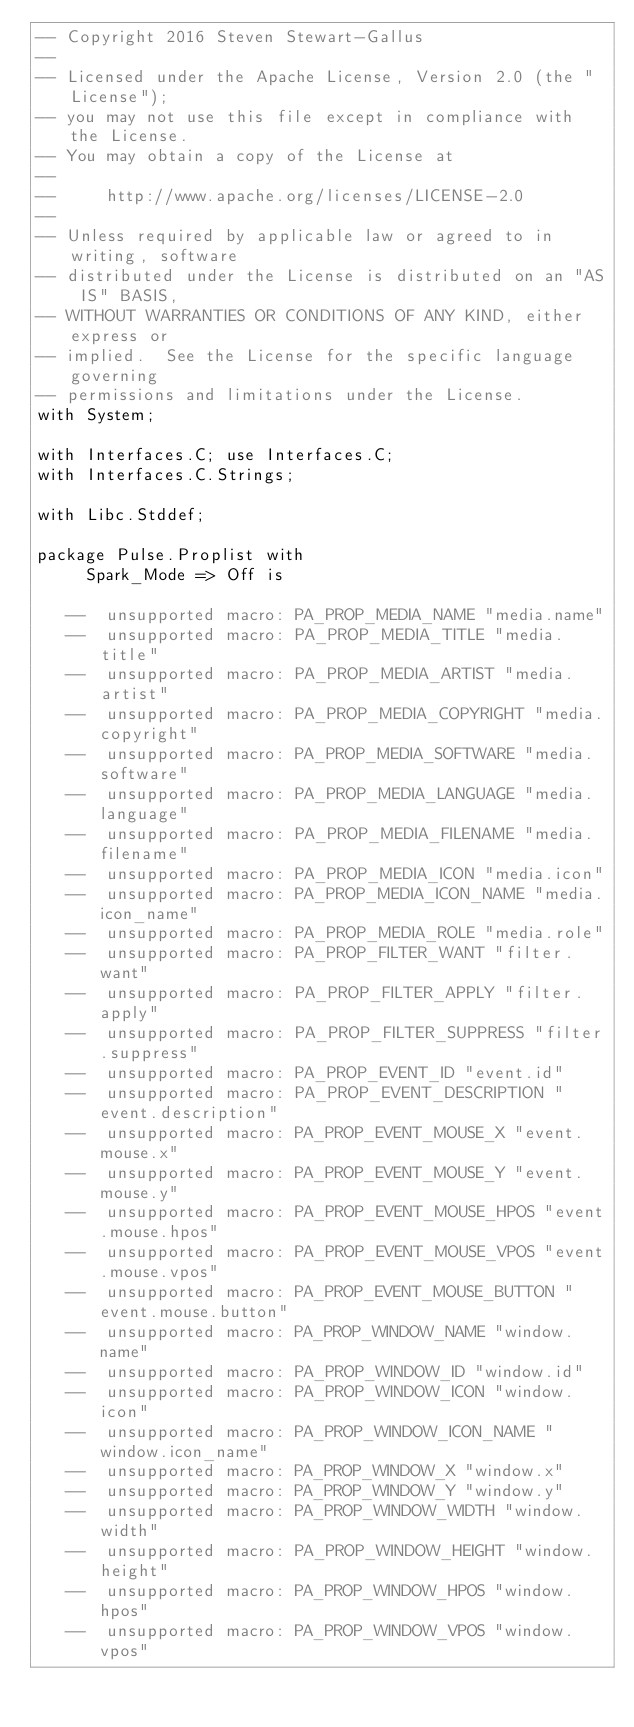Convert code to text. <code><loc_0><loc_0><loc_500><loc_500><_Ada_>-- Copyright 2016 Steven Stewart-Gallus
--
-- Licensed under the Apache License, Version 2.0 (the "License");
-- you may not use this file except in compliance with the License.
-- You may obtain a copy of the License at
--
--     http://www.apache.org/licenses/LICENSE-2.0
--
-- Unless required by applicable law or agreed to in writing, software
-- distributed under the License is distributed on an "AS IS" BASIS,
-- WITHOUT WARRANTIES OR CONDITIONS OF ANY KIND, either express or
-- implied.  See the License for the specific language governing
-- permissions and limitations under the License.
with System;

with Interfaces.C; use Interfaces.C;
with Interfaces.C.Strings;

with Libc.Stddef;

package Pulse.Proplist with
     Spark_Mode => Off is

   --  unsupported macro: PA_PROP_MEDIA_NAME "media.name"
   --  unsupported macro: PA_PROP_MEDIA_TITLE "media.title"
   --  unsupported macro: PA_PROP_MEDIA_ARTIST "media.artist"
   --  unsupported macro: PA_PROP_MEDIA_COPYRIGHT "media.copyright"
   --  unsupported macro: PA_PROP_MEDIA_SOFTWARE "media.software"
   --  unsupported macro: PA_PROP_MEDIA_LANGUAGE "media.language"
   --  unsupported macro: PA_PROP_MEDIA_FILENAME "media.filename"
   --  unsupported macro: PA_PROP_MEDIA_ICON "media.icon"
   --  unsupported macro: PA_PROP_MEDIA_ICON_NAME "media.icon_name"
   --  unsupported macro: PA_PROP_MEDIA_ROLE "media.role"
   --  unsupported macro: PA_PROP_FILTER_WANT "filter.want"
   --  unsupported macro: PA_PROP_FILTER_APPLY "filter.apply"
   --  unsupported macro: PA_PROP_FILTER_SUPPRESS "filter.suppress"
   --  unsupported macro: PA_PROP_EVENT_ID "event.id"
   --  unsupported macro: PA_PROP_EVENT_DESCRIPTION "event.description"
   --  unsupported macro: PA_PROP_EVENT_MOUSE_X "event.mouse.x"
   --  unsupported macro: PA_PROP_EVENT_MOUSE_Y "event.mouse.y"
   --  unsupported macro: PA_PROP_EVENT_MOUSE_HPOS "event.mouse.hpos"
   --  unsupported macro: PA_PROP_EVENT_MOUSE_VPOS "event.mouse.vpos"
   --  unsupported macro: PA_PROP_EVENT_MOUSE_BUTTON "event.mouse.button"
   --  unsupported macro: PA_PROP_WINDOW_NAME "window.name"
   --  unsupported macro: PA_PROP_WINDOW_ID "window.id"
   --  unsupported macro: PA_PROP_WINDOW_ICON "window.icon"
   --  unsupported macro: PA_PROP_WINDOW_ICON_NAME "window.icon_name"
   --  unsupported macro: PA_PROP_WINDOW_X "window.x"
   --  unsupported macro: PA_PROP_WINDOW_Y "window.y"
   --  unsupported macro: PA_PROP_WINDOW_WIDTH "window.width"
   --  unsupported macro: PA_PROP_WINDOW_HEIGHT "window.height"
   --  unsupported macro: PA_PROP_WINDOW_HPOS "window.hpos"
   --  unsupported macro: PA_PROP_WINDOW_VPOS "window.vpos"</code> 